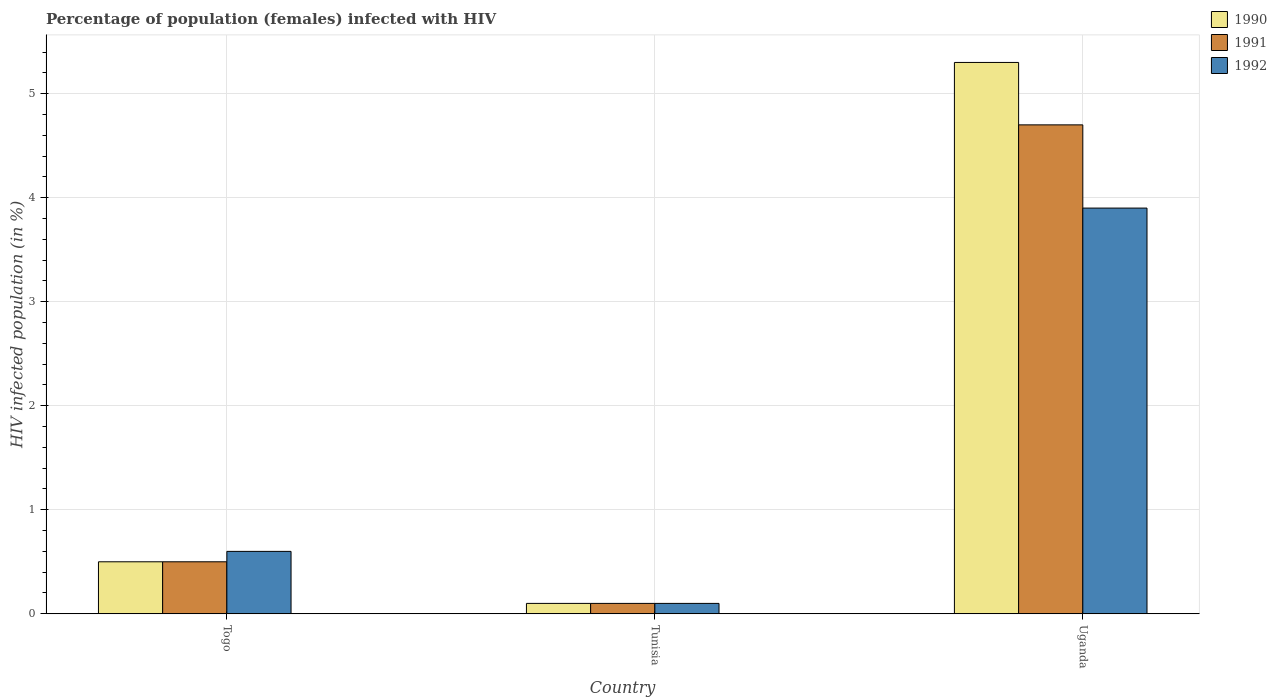How many different coloured bars are there?
Keep it short and to the point. 3. Are the number of bars per tick equal to the number of legend labels?
Offer a terse response. Yes. Are the number of bars on each tick of the X-axis equal?
Keep it short and to the point. Yes. How many bars are there on the 2nd tick from the right?
Your answer should be very brief. 3. What is the label of the 2nd group of bars from the left?
Your answer should be compact. Tunisia. In how many cases, is the number of bars for a given country not equal to the number of legend labels?
Your answer should be very brief. 0. What is the percentage of HIV infected female population in 1990 in Uganda?
Your answer should be compact. 5.3. Across all countries, what is the maximum percentage of HIV infected female population in 1992?
Give a very brief answer. 3.9. Across all countries, what is the minimum percentage of HIV infected female population in 1992?
Provide a short and direct response. 0.1. In which country was the percentage of HIV infected female population in 1992 maximum?
Provide a succinct answer. Uganda. In which country was the percentage of HIV infected female population in 1992 minimum?
Make the answer very short. Tunisia. What is the difference between the percentage of HIV infected female population in 1990 in Togo and that in Uganda?
Offer a very short reply. -4.8. What is the average percentage of HIV infected female population in 1990 per country?
Your answer should be very brief. 1.97. What is the difference between the percentage of HIV infected female population of/in 1991 and percentage of HIV infected female population of/in 1992 in Uganda?
Ensure brevity in your answer.  0.8. In how many countries, is the percentage of HIV infected female population in 1990 greater than 2 %?
Your answer should be very brief. 1. What is the ratio of the percentage of HIV infected female population in 1990 in Tunisia to that in Uganda?
Ensure brevity in your answer.  0.02. Is the percentage of HIV infected female population in 1990 in Togo less than that in Tunisia?
Provide a succinct answer. No. What is the difference between the highest and the second highest percentage of HIV infected female population in 1992?
Your answer should be very brief. -3.3. What is the difference between the highest and the lowest percentage of HIV infected female population in 1990?
Make the answer very short. 5.2. In how many countries, is the percentage of HIV infected female population in 1990 greater than the average percentage of HIV infected female population in 1990 taken over all countries?
Your response must be concise. 1. Is the sum of the percentage of HIV infected female population in 1991 in Togo and Uganda greater than the maximum percentage of HIV infected female population in 1990 across all countries?
Keep it short and to the point. No. What does the 3rd bar from the left in Tunisia represents?
Ensure brevity in your answer.  1992. What does the 1st bar from the right in Tunisia represents?
Keep it short and to the point. 1992. Are all the bars in the graph horizontal?
Make the answer very short. No. How many countries are there in the graph?
Give a very brief answer. 3. Are the values on the major ticks of Y-axis written in scientific E-notation?
Your answer should be very brief. No. How many legend labels are there?
Your answer should be compact. 3. What is the title of the graph?
Offer a very short reply. Percentage of population (females) infected with HIV. Does "1972" appear as one of the legend labels in the graph?
Give a very brief answer. No. What is the label or title of the X-axis?
Ensure brevity in your answer.  Country. What is the label or title of the Y-axis?
Offer a terse response. HIV infected population (in %). What is the HIV infected population (in %) of 1990 in Togo?
Provide a succinct answer. 0.5. What is the HIV infected population (in %) in 1992 in Tunisia?
Your answer should be very brief. 0.1. Across all countries, what is the minimum HIV infected population (in %) of 1991?
Offer a terse response. 0.1. What is the total HIV infected population (in %) of 1990 in the graph?
Your answer should be very brief. 5.9. What is the total HIV infected population (in %) in 1992 in the graph?
Ensure brevity in your answer.  4.6. What is the difference between the HIV infected population (in %) of 1990 in Togo and that in Tunisia?
Make the answer very short. 0.4. What is the difference between the HIV infected population (in %) in 1992 in Togo and that in Tunisia?
Provide a short and direct response. 0.5. What is the difference between the HIV infected population (in %) in 1991 in Togo and that in Uganda?
Your response must be concise. -4.2. What is the difference between the HIV infected population (in %) of 1992 in Togo and that in Uganda?
Your response must be concise. -3.3. What is the difference between the HIV infected population (in %) in 1991 in Tunisia and that in Uganda?
Ensure brevity in your answer.  -4.6. What is the difference between the HIV infected population (in %) in 1990 in Togo and the HIV infected population (in %) in 1991 in Tunisia?
Provide a short and direct response. 0.4. What is the difference between the HIV infected population (in %) of 1990 in Tunisia and the HIV infected population (in %) of 1992 in Uganda?
Your answer should be compact. -3.8. What is the average HIV infected population (in %) in 1990 per country?
Offer a terse response. 1.97. What is the average HIV infected population (in %) of 1991 per country?
Ensure brevity in your answer.  1.77. What is the average HIV infected population (in %) in 1992 per country?
Give a very brief answer. 1.53. What is the difference between the HIV infected population (in %) in 1991 and HIV infected population (in %) in 1992 in Togo?
Provide a succinct answer. -0.1. What is the difference between the HIV infected population (in %) of 1990 and HIV infected population (in %) of 1991 in Uganda?
Your response must be concise. 0.6. What is the difference between the HIV infected population (in %) in 1990 and HIV infected population (in %) in 1992 in Uganda?
Make the answer very short. 1.4. What is the ratio of the HIV infected population (in %) of 1990 in Togo to that in Uganda?
Your answer should be very brief. 0.09. What is the ratio of the HIV infected population (in %) in 1991 in Togo to that in Uganda?
Provide a succinct answer. 0.11. What is the ratio of the HIV infected population (in %) in 1992 in Togo to that in Uganda?
Offer a terse response. 0.15. What is the ratio of the HIV infected population (in %) in 1990 in Tunisia to that in Uganda?
Your answer should be very brief. 0.02. What is the ratio of the HIV infected population (in %) of 1991 in Tunisia to that in Uganda?
Offer a very short reply. 0.02. What is the ratio of the HIV infected population (in %) of 1992 in Tunisia to that in Uganda?
Give a very brief answer. 0.03. What is the difference between the highest and the second highest HIV infected population (in %) of 1992?
Keep it short and to the point. 3.3. What is the difference between the highest and the lowest HIV infected population (in %) of 1991?
Your response must be concise. 4.6. 